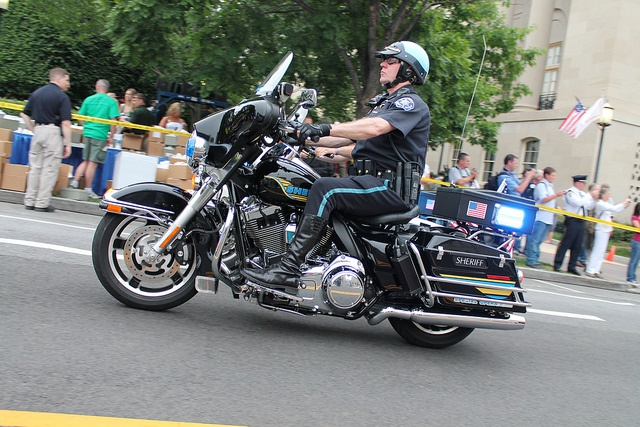Describe the objects in this image and their specific colors. I can see motorcycle in white, black, darkgray, and gray tones, people in white, black, gray, and lightgray tones, people in white, lightgray, darkgray, and black tones, people in white, turquoise, gray, and darkgray tones, and people in white, black, lavender, and darkgray tones in this image. 